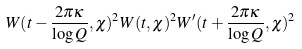Convert formula to latex. <formula><loc_0><loc_0><loc_500><loc_500>W ( t - \frac { 2 \pi \kappa } { \log Q } , \chi ) ^ { 2 } W ( t , \chi ) ^ { 2 } W ^ { \prime } ( t + \frac { 2 \pi \kappa } { \log Q } , \chi ) ^ { 2 }</formula> 